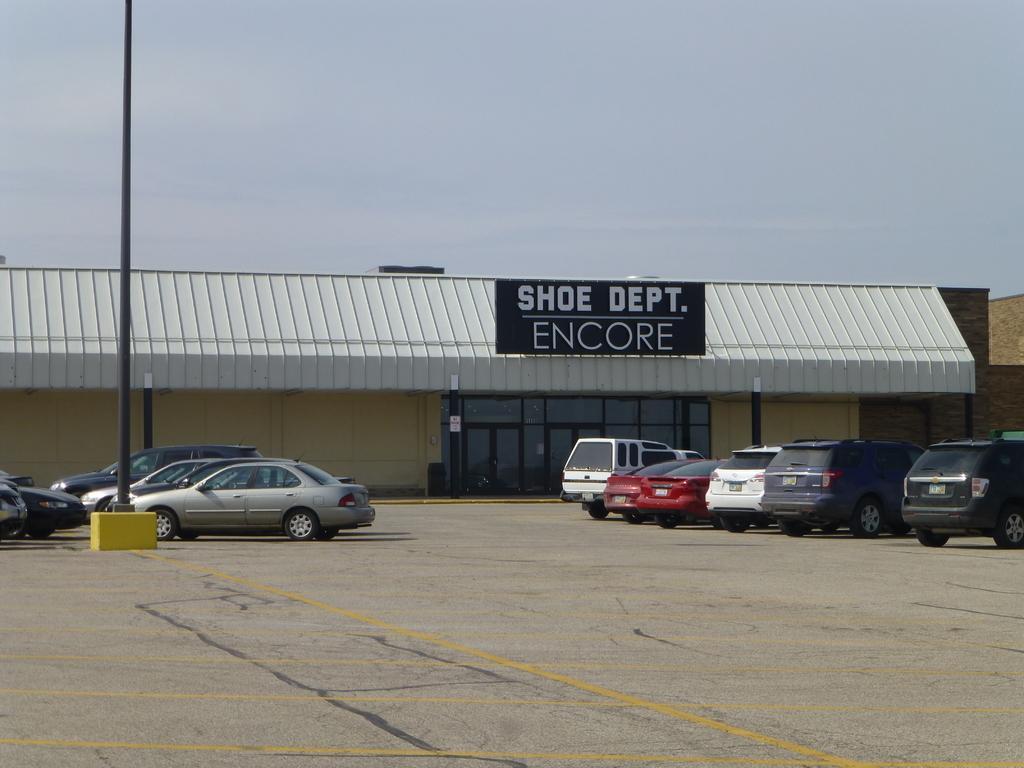Can you describe this image briefly? In the picture we can see a clear surface and far away from it we can see some vehicles are parked on both the sides and near it we can see a pole and in the background we can see a shed with a name shoe dept encore and behind it we can see the sky. 